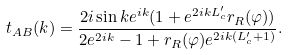Convert formula to latex. <formula><loc_0><loc_0><loc_500><loc_500>t _ { A B } ( k ) = \frac { 2 i \sin k e ^ { i k } ( 1 + e ^ { 2 i k L ^ { \prime } _ { c } } r _ { R } ( \varphi ) ) } { 2 e ^ { 2 i k } - 1 + r _ { R } ( \varphi ) e ^ { 2 i k ( L ^ { \prime } _ { c } + 1 ) } } .</formula> 